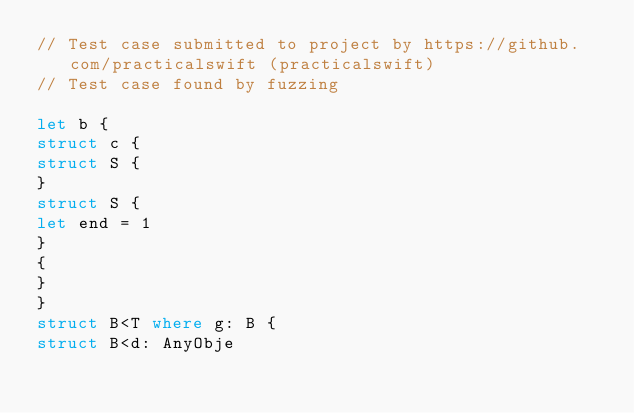<code> <loc_0><loc_0><loc_500><loc_500><_Swift_>// Test case submitted to project by https://github.com/practicalswift (practicalswift)
// Test case found by fuzzing

let b {
struct c {
struct S {
}
struct S {
let end = 1
}
{
}
}
struct B<T where g: B {
struct B<d: AnyObje
</code> 